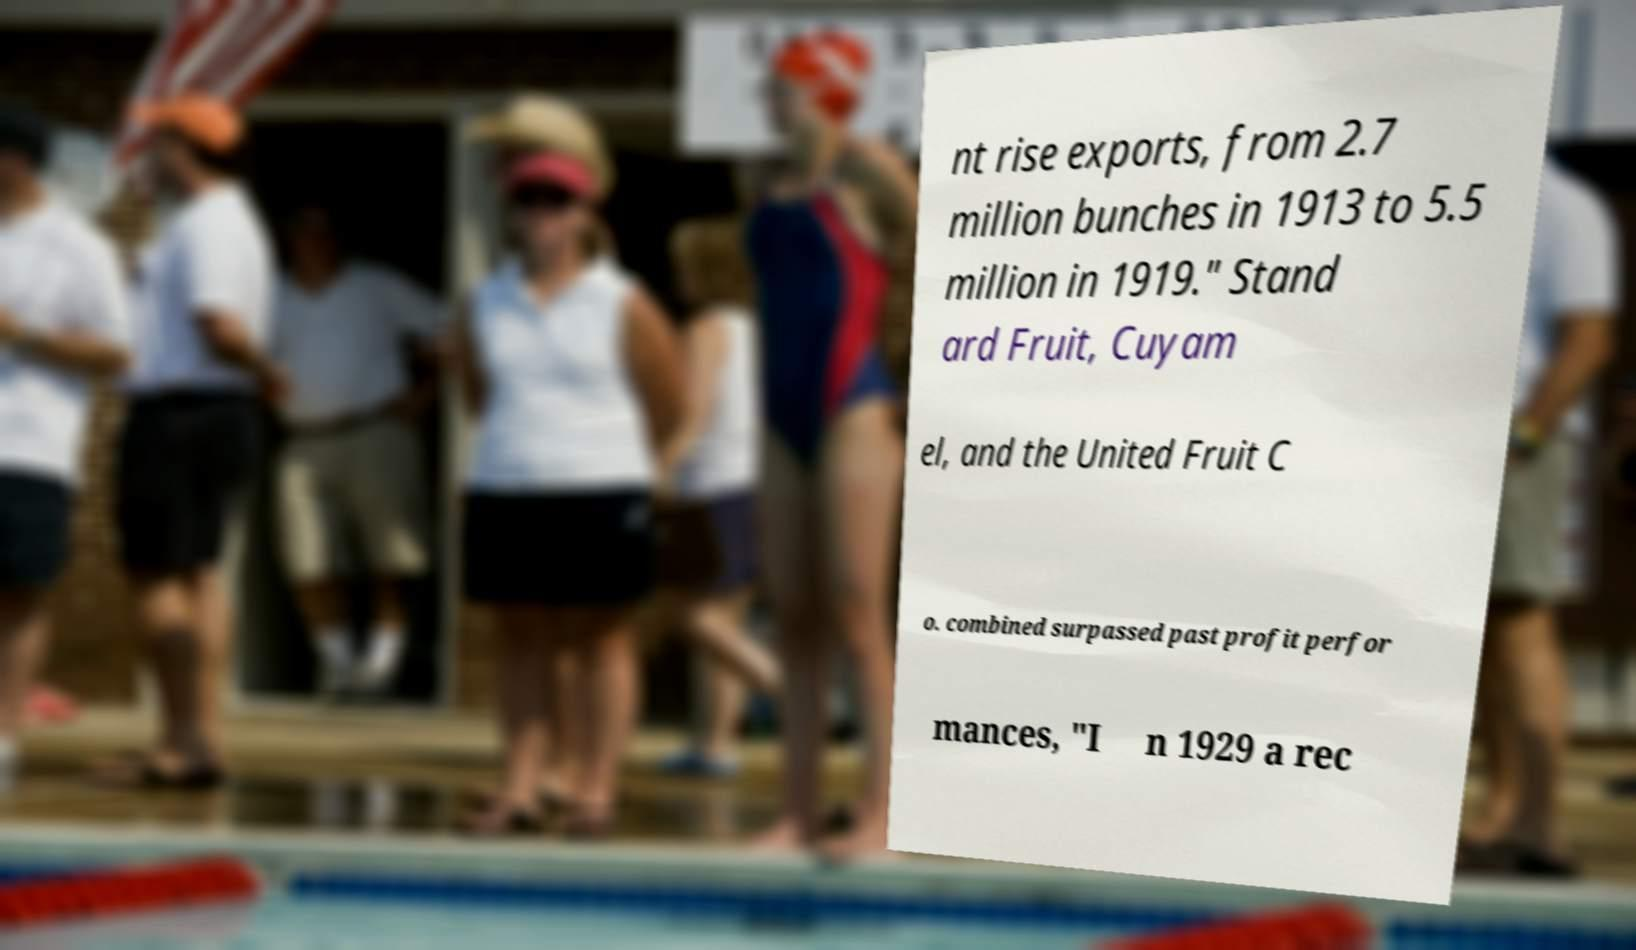For documentation purposes, I need the text within this image transcribed. Could you provide that? nt rise exports, from 2.7 million bunches in 1913 to 5.5 million in 1919." Stand ard Fruit, Cuyam el, and the United Fruit C o. combined surpassed past profit perfor mances, "I n 1929 a rec 